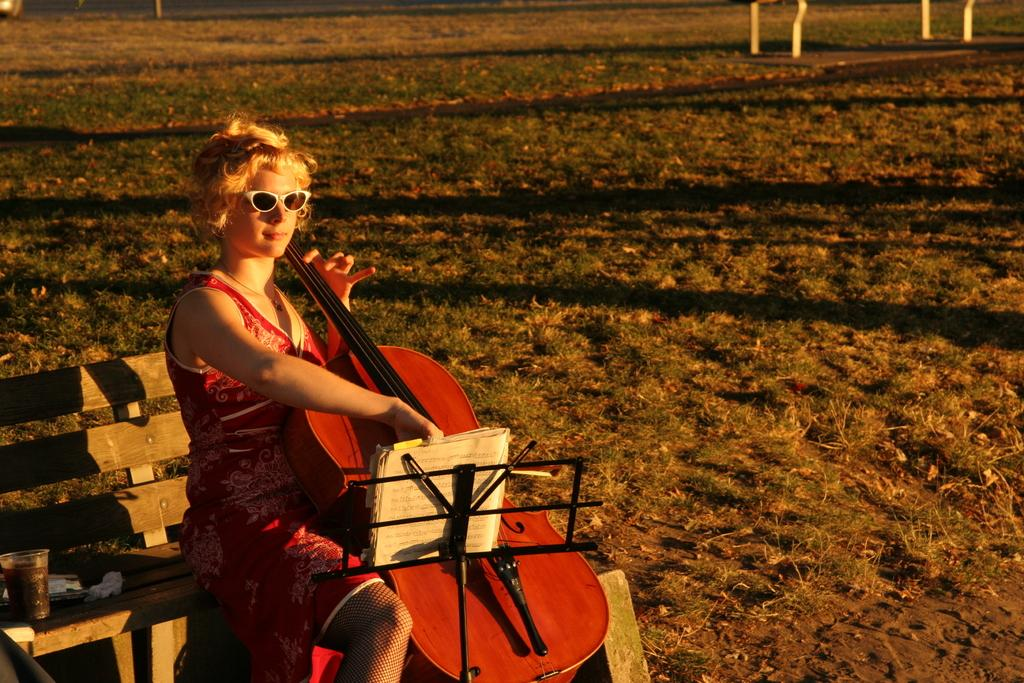Who is the main subject in the image? There is a woman in the image. What is the woman doing in the image? The woman is sitting on a bench and playing the guitar. What else is the woman doing while playing the guitar? The woman is looking into a book while playing the guitar. What type of surface is the woman sitting on in the image? There is grass in the image, which suggests that the woman is sitting on a grassy surface. Reasoning: Let' Let's think step by step in order to produce the conversation. We start by identifying the main subject in the image, which is the woman. Then, we describe her actions and the objects she is interacting with, such as the bench, guitar, and book. We also mention the grassy surface she is sitting on. Each question is designed to elicit a specific detail about the image that is known from the provided facts. Absurd Question/Answer: What rhythm is the woman's grandfather playing on the side of the bench in the image? There is no mention of a grandfather or rhythm in the image, and the woman is the only person present. 